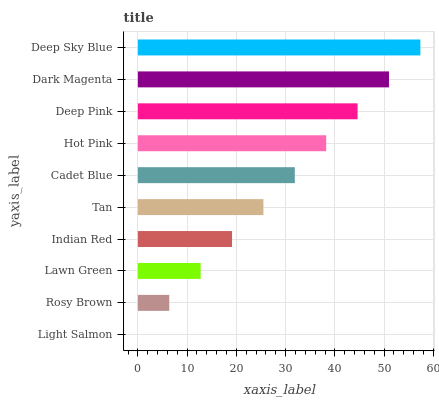Is Light Salmon the minimum?
Answer yes or no. Yes. Is Deep Sky Blue the maximum?
Answer yes or no. Yes. Is Rosy Brown the minimum?
Answer yes or no. No. Is Rosy Brown the maximum?
Answer yes or no. No. Is Rosy Brown greater than Light Salmon?
Answer yes or no. Yes. Is Light Salmon less than Rosy Brown?
Answer yes or no. Yes. Is Light Salmon greater than Rosy Brown?
Answer yes or no. No. Is Rosy Brown less than Light Salmon?
Answer yes or no. No. Is Cadet Blue the high median?
Answer yes or no. Yes. Is Tan the low median?
Answer yes or no. Yes. Is Hot Pink the high median?
Answer yes or no. No. Is Rosy Brown the low median?
Answer yes or no. No. 